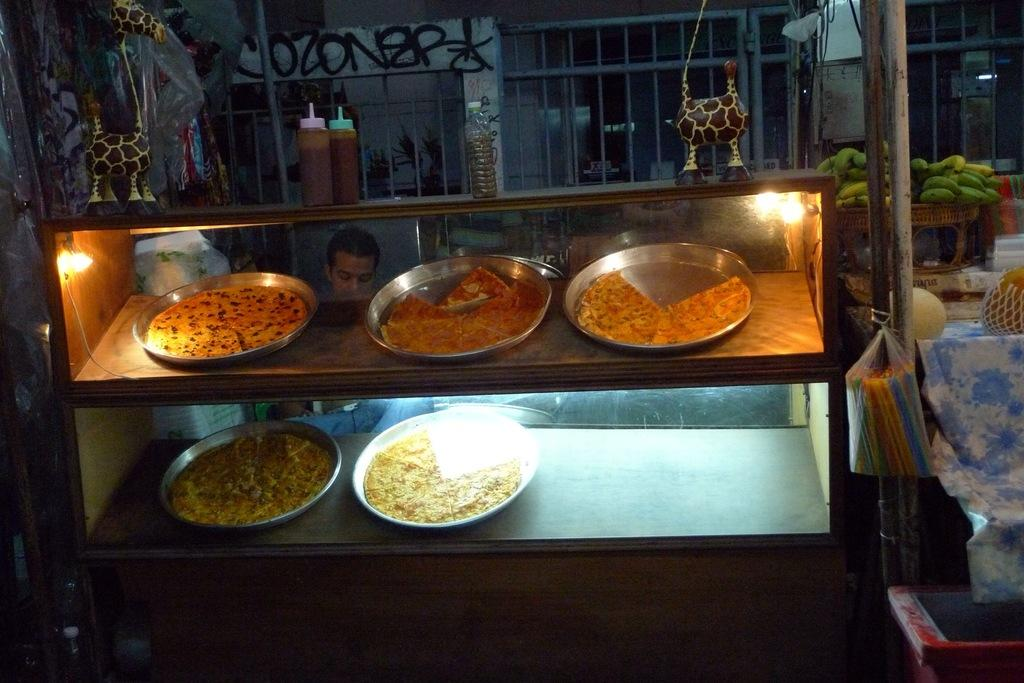What type of container is used to hold the eatables in the image? There are eatables placed in a steel plate in the image. Can you describe the person in the background of the image? Unfortunately, the facts provided do not give any details about the person in the background. How many cattle are visible in the image? There are no cattle present in the image. What type of tooth can be seen in the image? There is no tooth present in the image. 